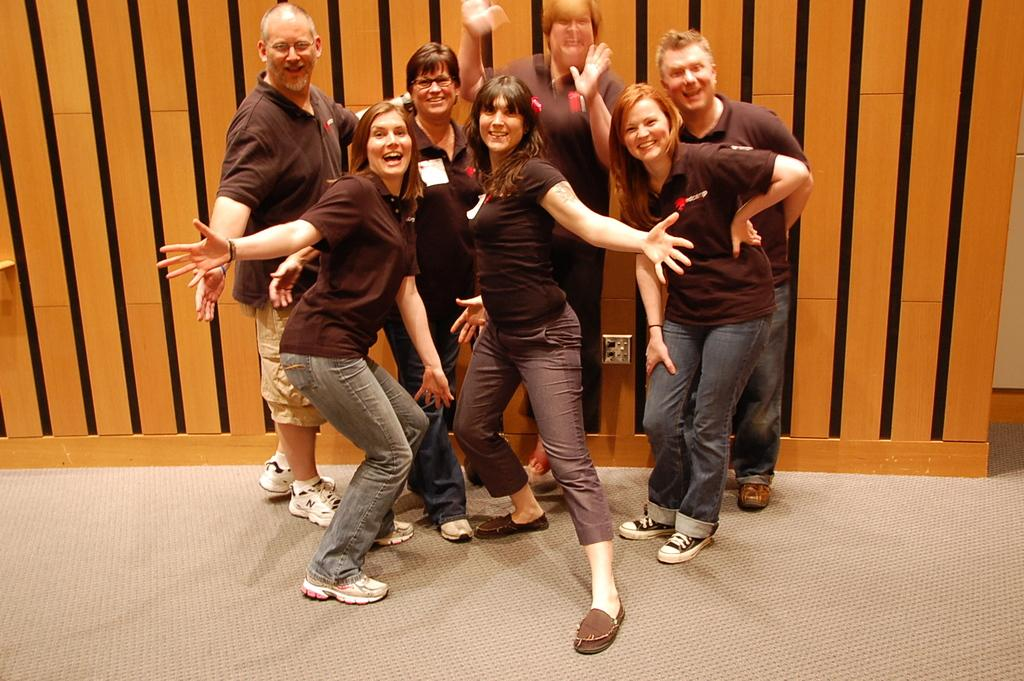What is the main subject of the image? The main subject of the image is a group of people. Where are the people located in the image? The people are standing on the floor. What can be seen in the background of the image? There is a wall visible in the background of the image. What type of brush is being used by the people in the image? There is no brush present in the image; the people are simply standing on the floor. 